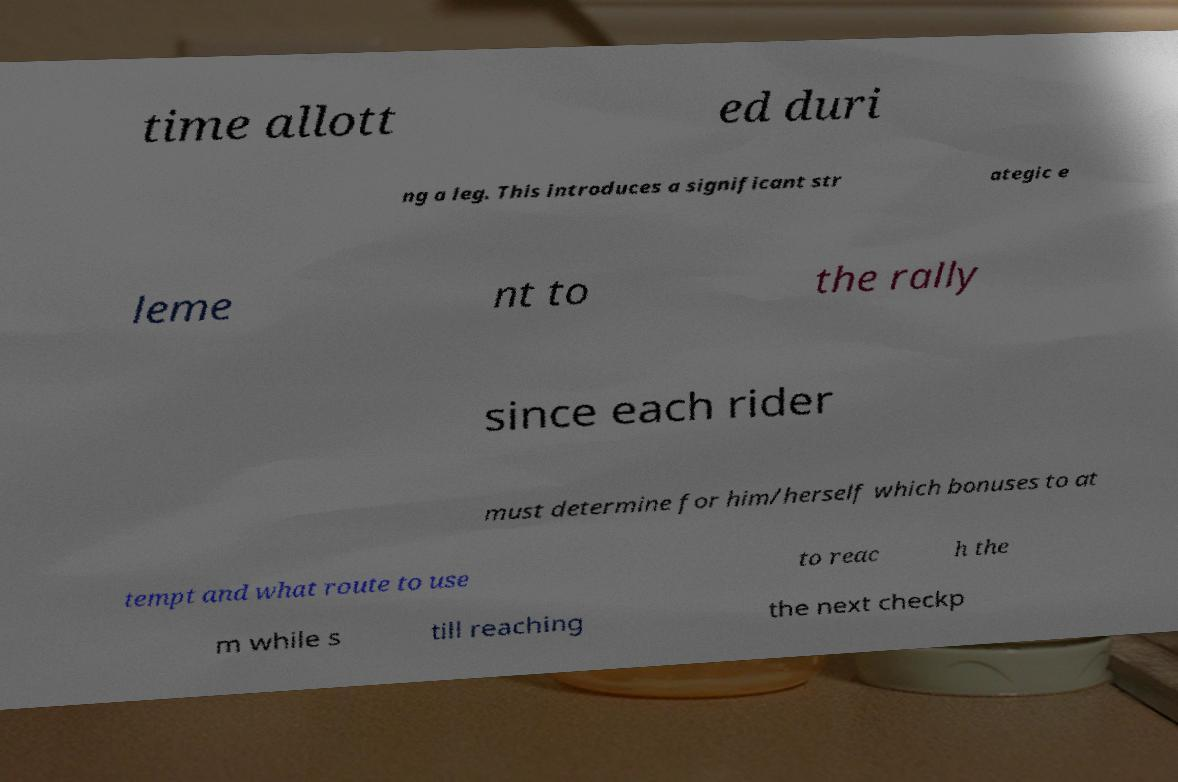Can you read and provide the text displayed in the image?This photo seems to have some interesting text. Can you extract and type it out for me? time allott ed duri ng a leg. This introduces a significant str ategic e leme nt to the rally since each rider must determine for him/herself which bonuses to at tempt and what route to use to reac h the m while s till reaching the next checkp 